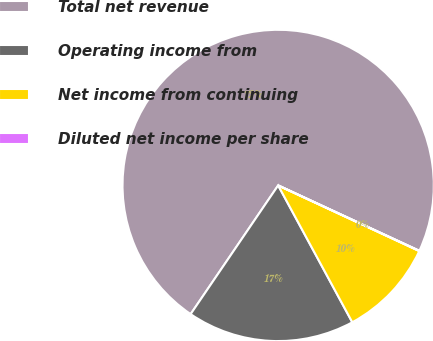Convert chart. <chart><loc_0><loc_0><loc_500><loc_500><pie_chart><fcel>Total net revenue<fcel>Operating income from<fcel>Net income from continuing<fcel>Diluted net income per share<nl><fcel>72.4%<fcel>17.41%<fcel>10.17%<fcel>0.03%<nl></chart> 